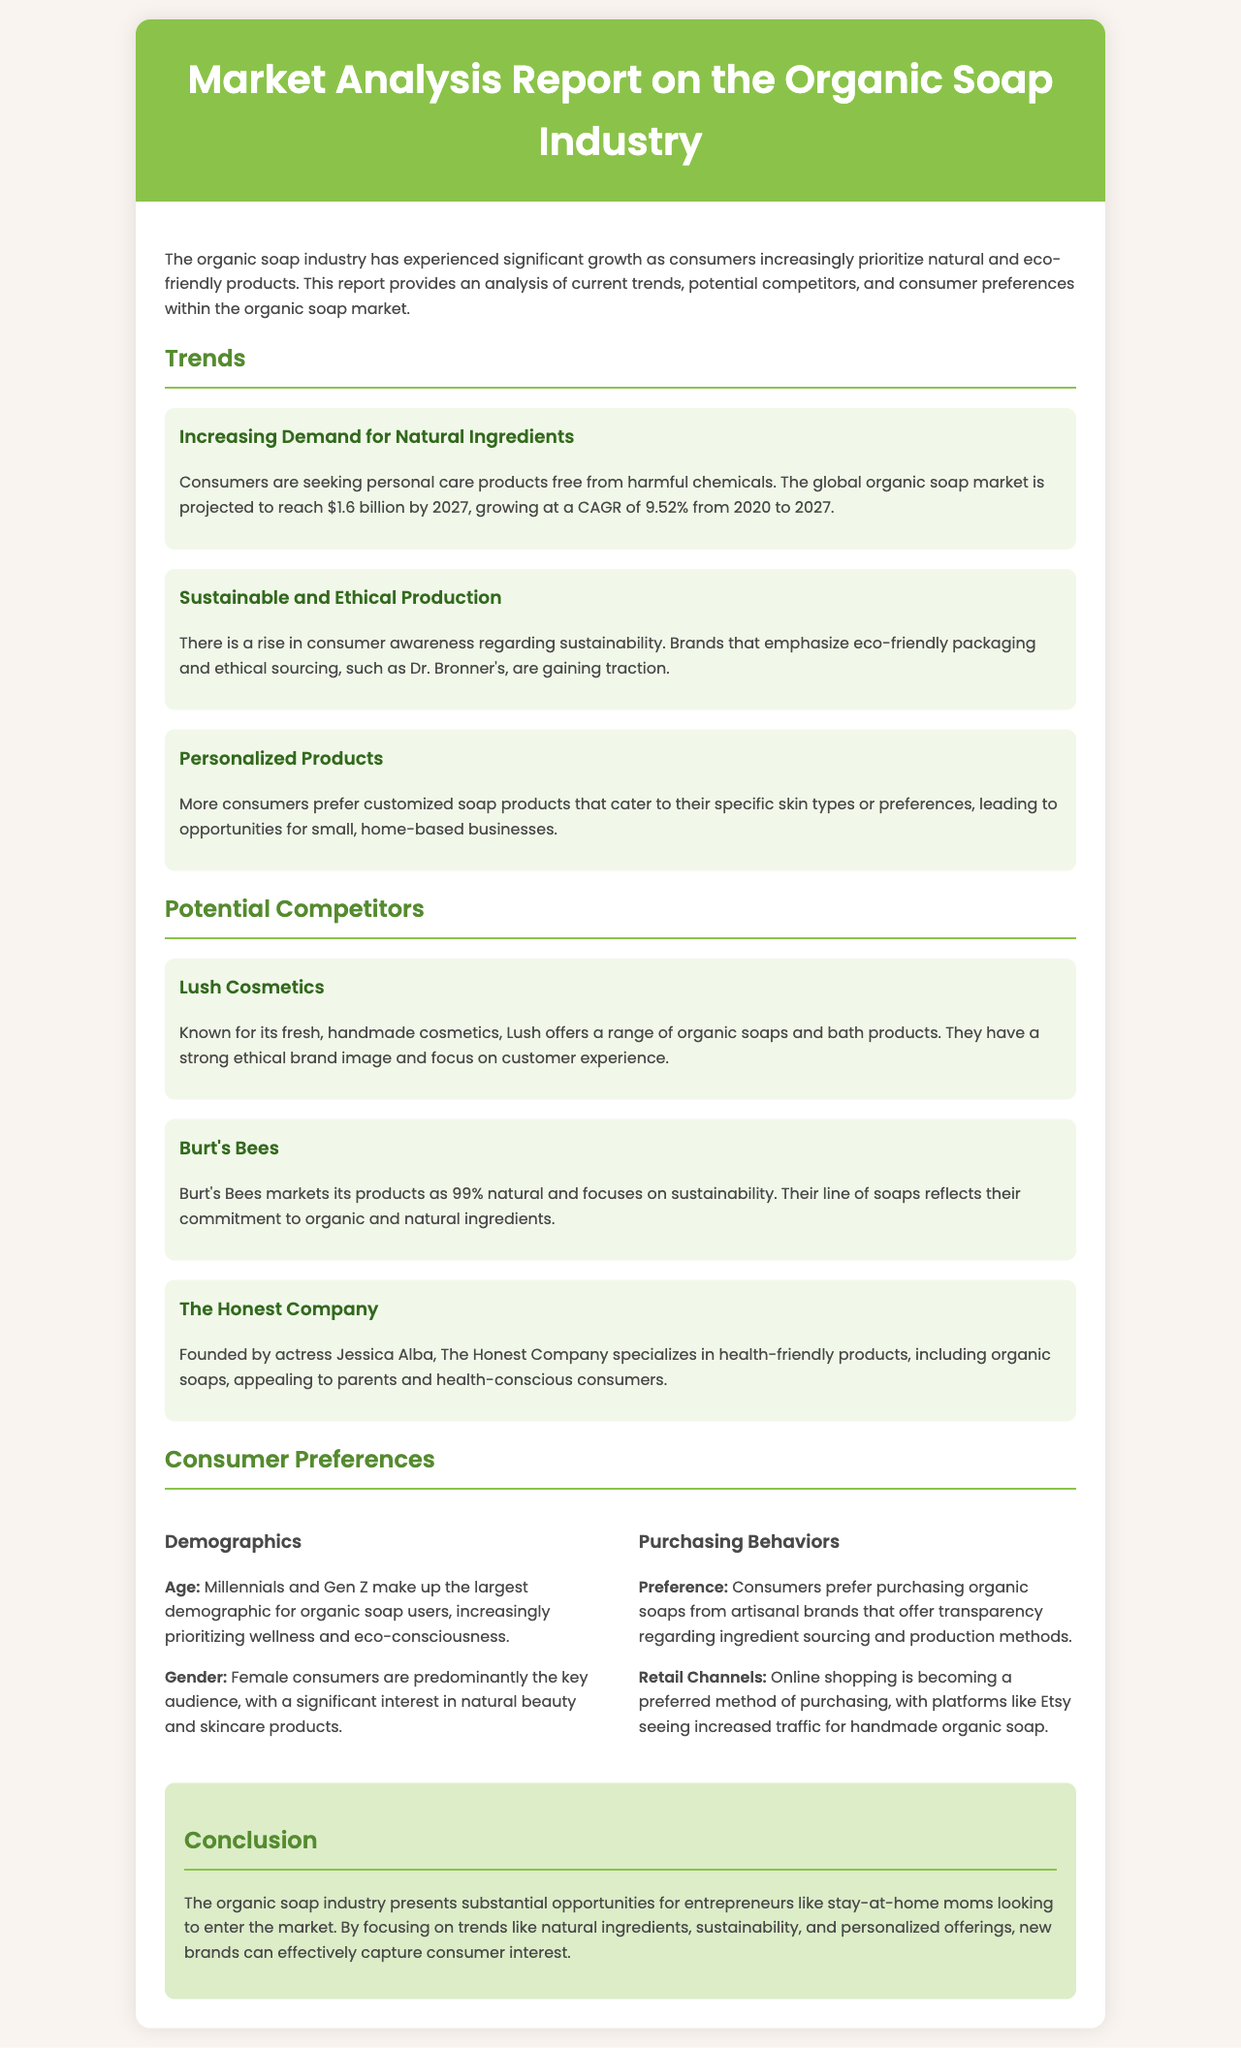What is the projected value of the global organic soap market by 2027? The projected value is mentioned as $1.6 billion by 2027 in the trends section.
Answer: $1.6 billion What is the CAGR for the organic soap market from 2020 to 2027? The document states that the CAGR is 9.52% from 2020 to 2027.
Answer: 9.52% Which brand emphasizes eco-friendly packaging and ethical sourcing? The report specifies Dr. Bronner's as a brand that emphasizes eco-friendly packaging and ethical sourcing.
Answer: Dr. Bronner's Who is the founder of The Honest Company? The report indicates that The Honest Company was founded by Jessica Alba.
Answer: Jessica Alba What demographic makes up the largest users of organic soap? According to the consumer preferences section, Millennials and Gen Z make up the largest demographic for organic soap users.
Answer: Millennials and Gen Z What is becoming the preferred retail channel for purchasing organic soaps? The document mentions that online shopping is becoming the preferred method of purchasing organic soaps.
Answer: Online shopping Which competitor is known for its fresh, handmade cosmetics? Lush Cosmetics is identified as the competitor known for its fresh, handmade cosmetics in the report.
Answer: Lush Cosmetics What percentage of Burt's Bees products is marketed as natural? The report states that Burt's Bees markets its products as 99% natural.
Answer: 99% What trend indicates a rise in consumer awareness regarding sustainability? The report highlights the trend of sustainable and ethical production as a response to consumer awareness regarding sustainability.
Answer: Sustainable and ethical production 